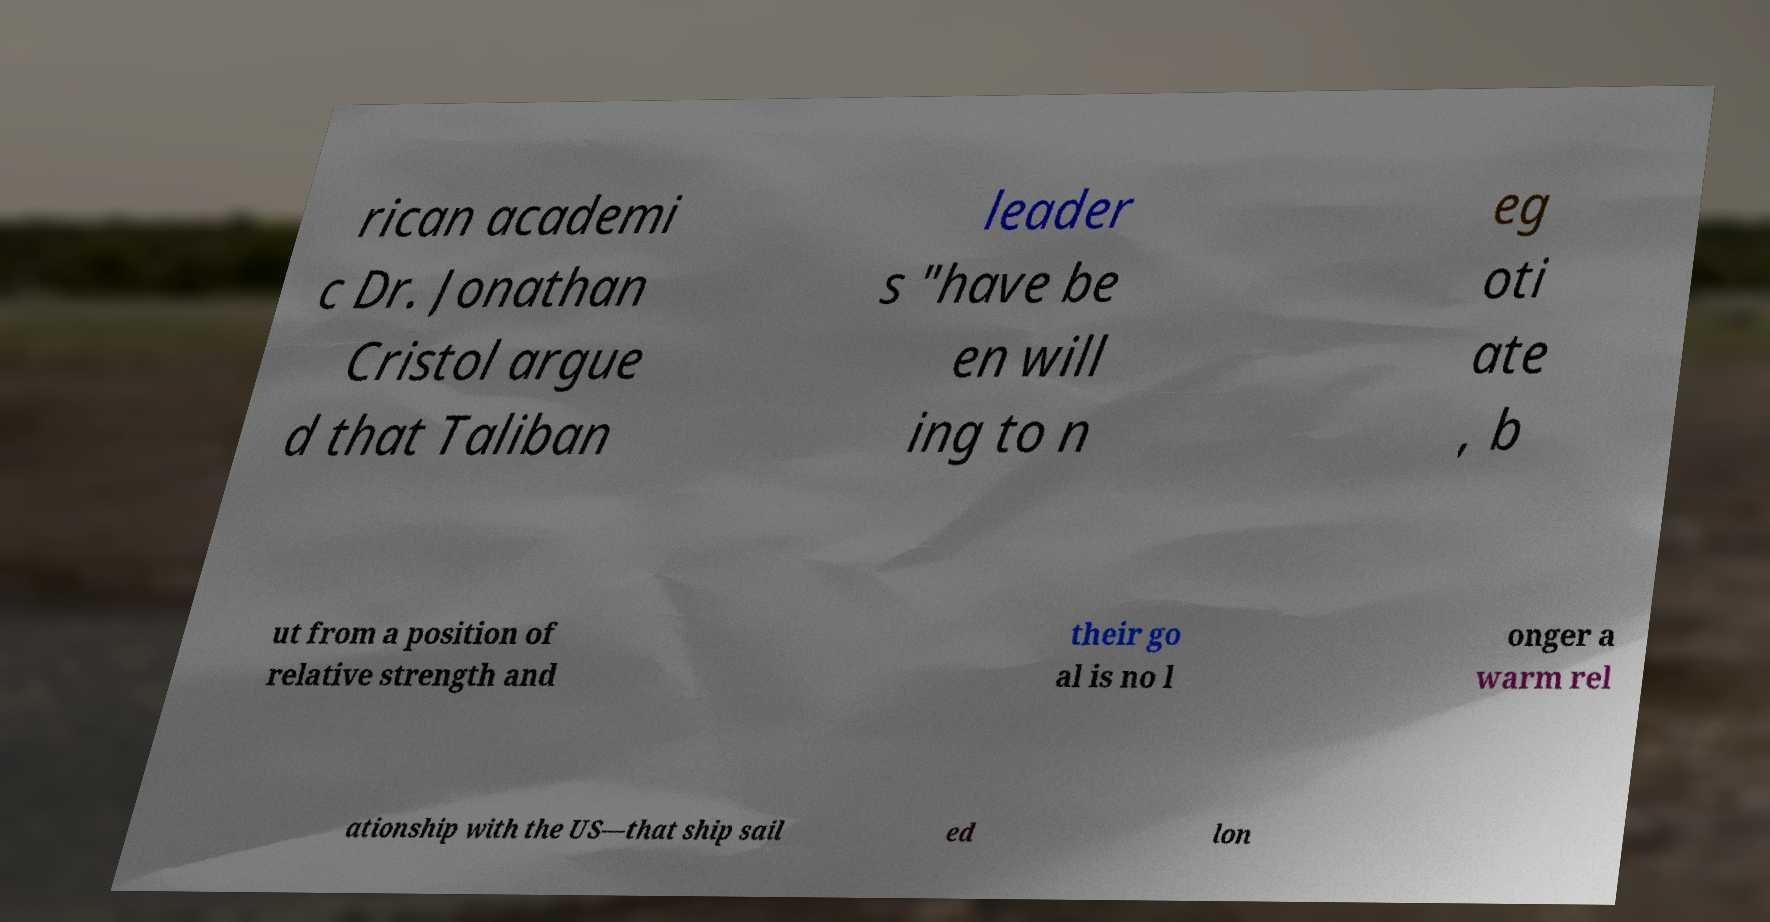Could you extract and type out the text from this image? rican academi c Dr. Jonathan Cristol argue d that Taliban leader s "have be en will ing to n eg oti ate , b ut from a position of relative strength and their go al is no l onger a warm rel ationship with the US—that ship sail ed lon 